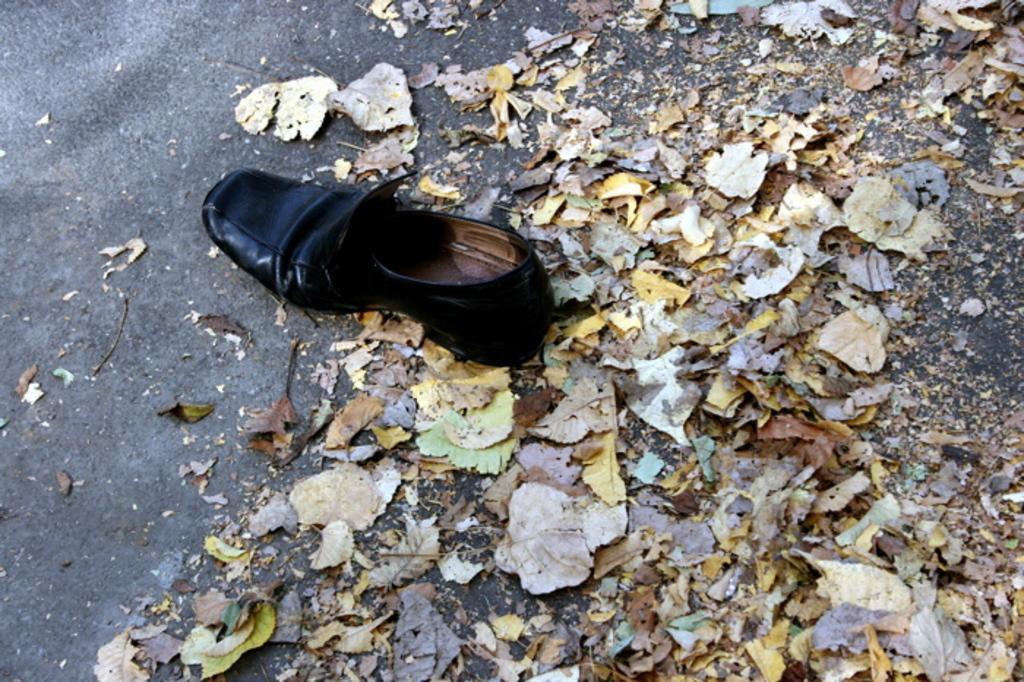How would you summarize this image in a sentence or two? In this image, we can see a black shoe on the road. Here we can see dry leaves. 